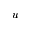Convert formula to latex. <formula><loc_0><loc_0><loc_500><loc_500>u</formula> 